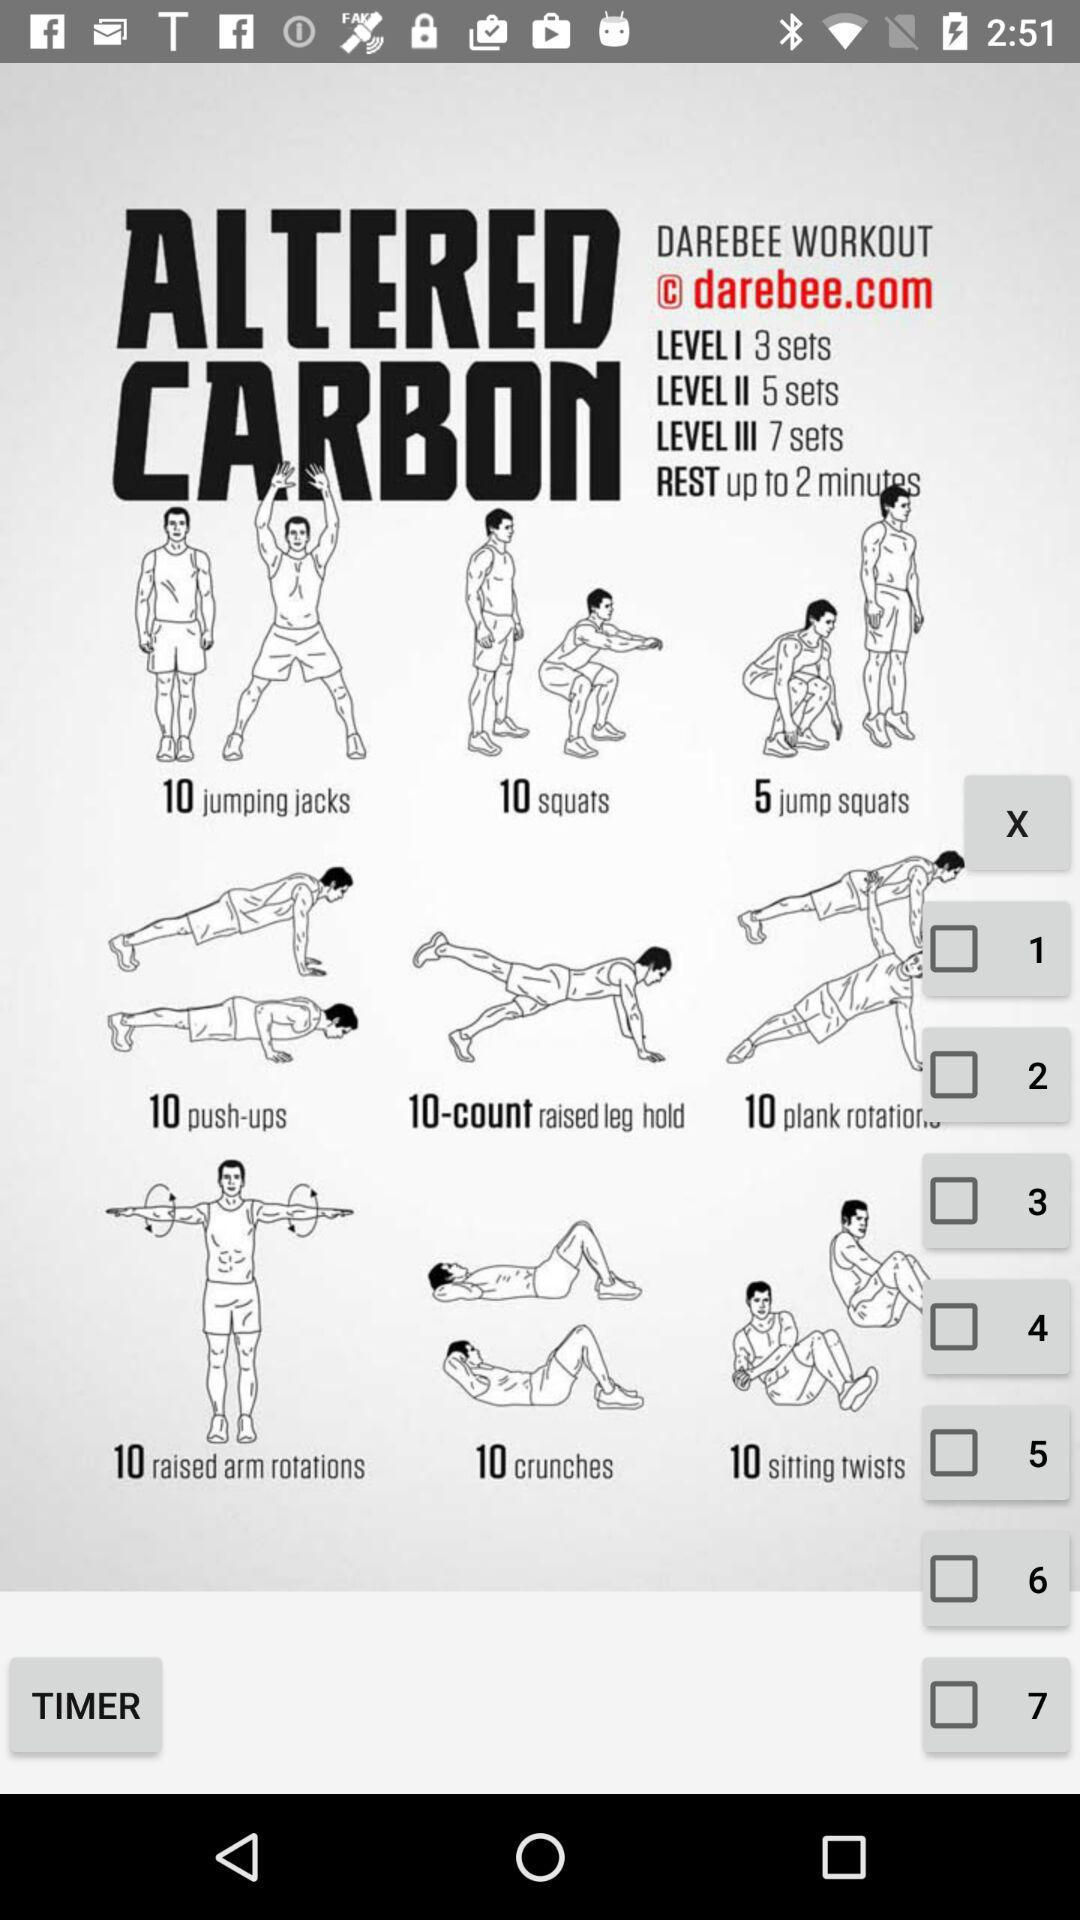How many jumping jacks will be done in one set? There will be 10 jumping jacks done in one set. 